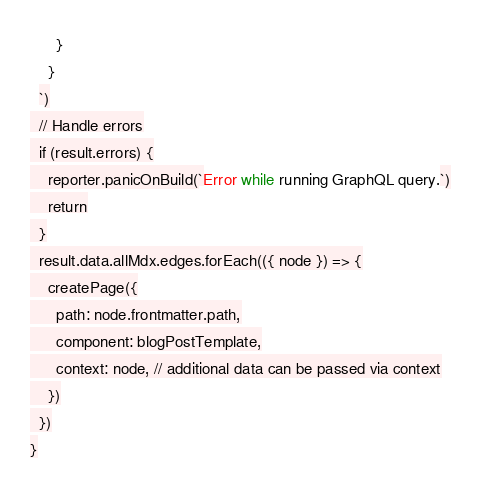<code> <loc_0><loc_0><loc_500><loc_500><_JavaScript_>      }
    }
  `)
  // Handle errors
  if (result.errors) {
    reporter.panicOnBuild(`Error while running GraphQL query.`)
    return
  }
  result.data.allMdx.edges.forEach(({ node }) => {
    createPage({
      path: node.frontmatter.path,
      component: blogPostTemplate,
      context: node, // additional data can be passed via context
    })
  })
}</code> 